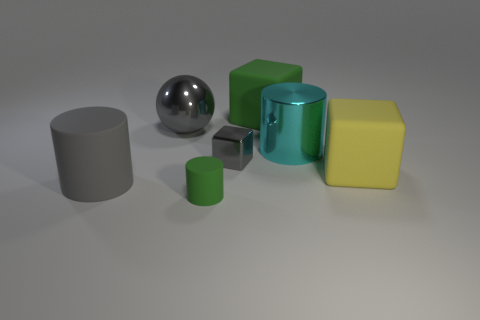Is the number of large gray spheres that are right of the shiny sphere the same as the number of large metal spheres? Upon examining the image, there appears to be one large gray sphere to the right of the shiny sphere. Comparing this to the number of large metal spheres, of which there is only one that is clearly visible in the image, the quantities are indeed the same. Each group consists of a single sphere, thus making their numbers equal. 